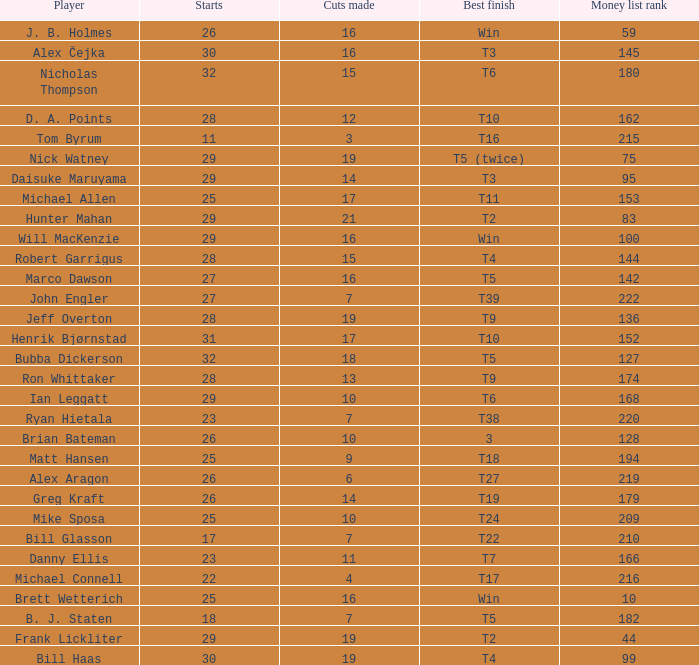What is the minimum number of starts for the players having a best finish of T18? 25.0. 